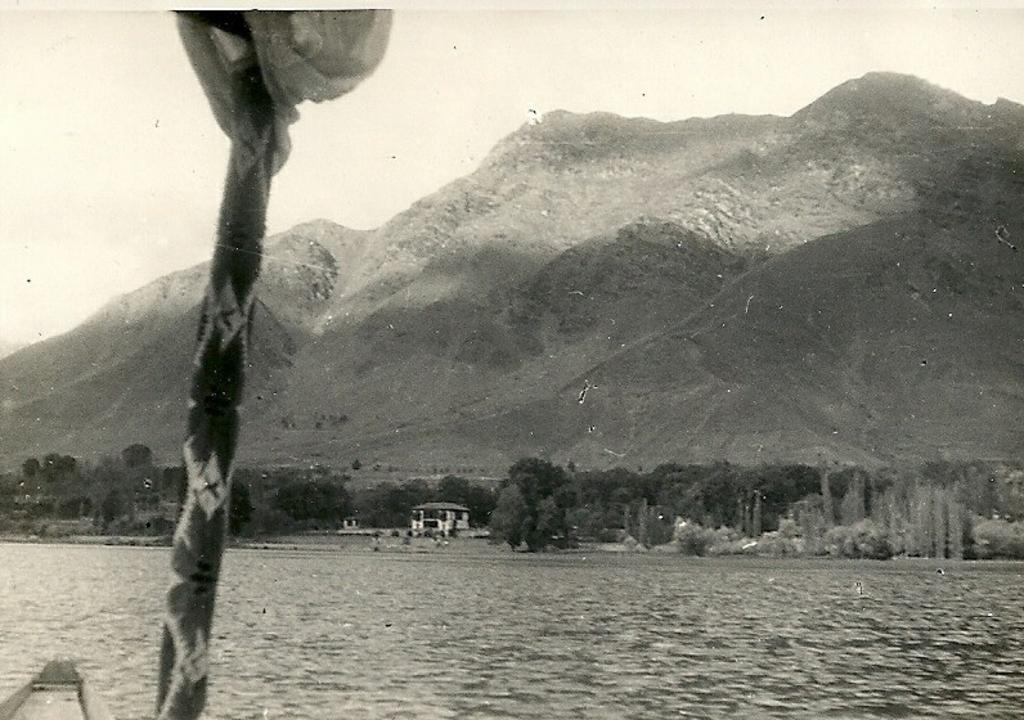What is the main subject of the image? The main subject of the image is a boat. Where is the boat located? The boat is on the water. What can be seen in the image besides the boat? There is an object that looks like a stick, trees, a building, mountains, and the sky visible in the image. What type of wool is being used to make the trousers in the image? There are no trousers or wool present in the image; it features a boat on the water with other background elements. How is the ice being used in the image? There is no ice present in the image; it features a boat on the water with other background elements. 